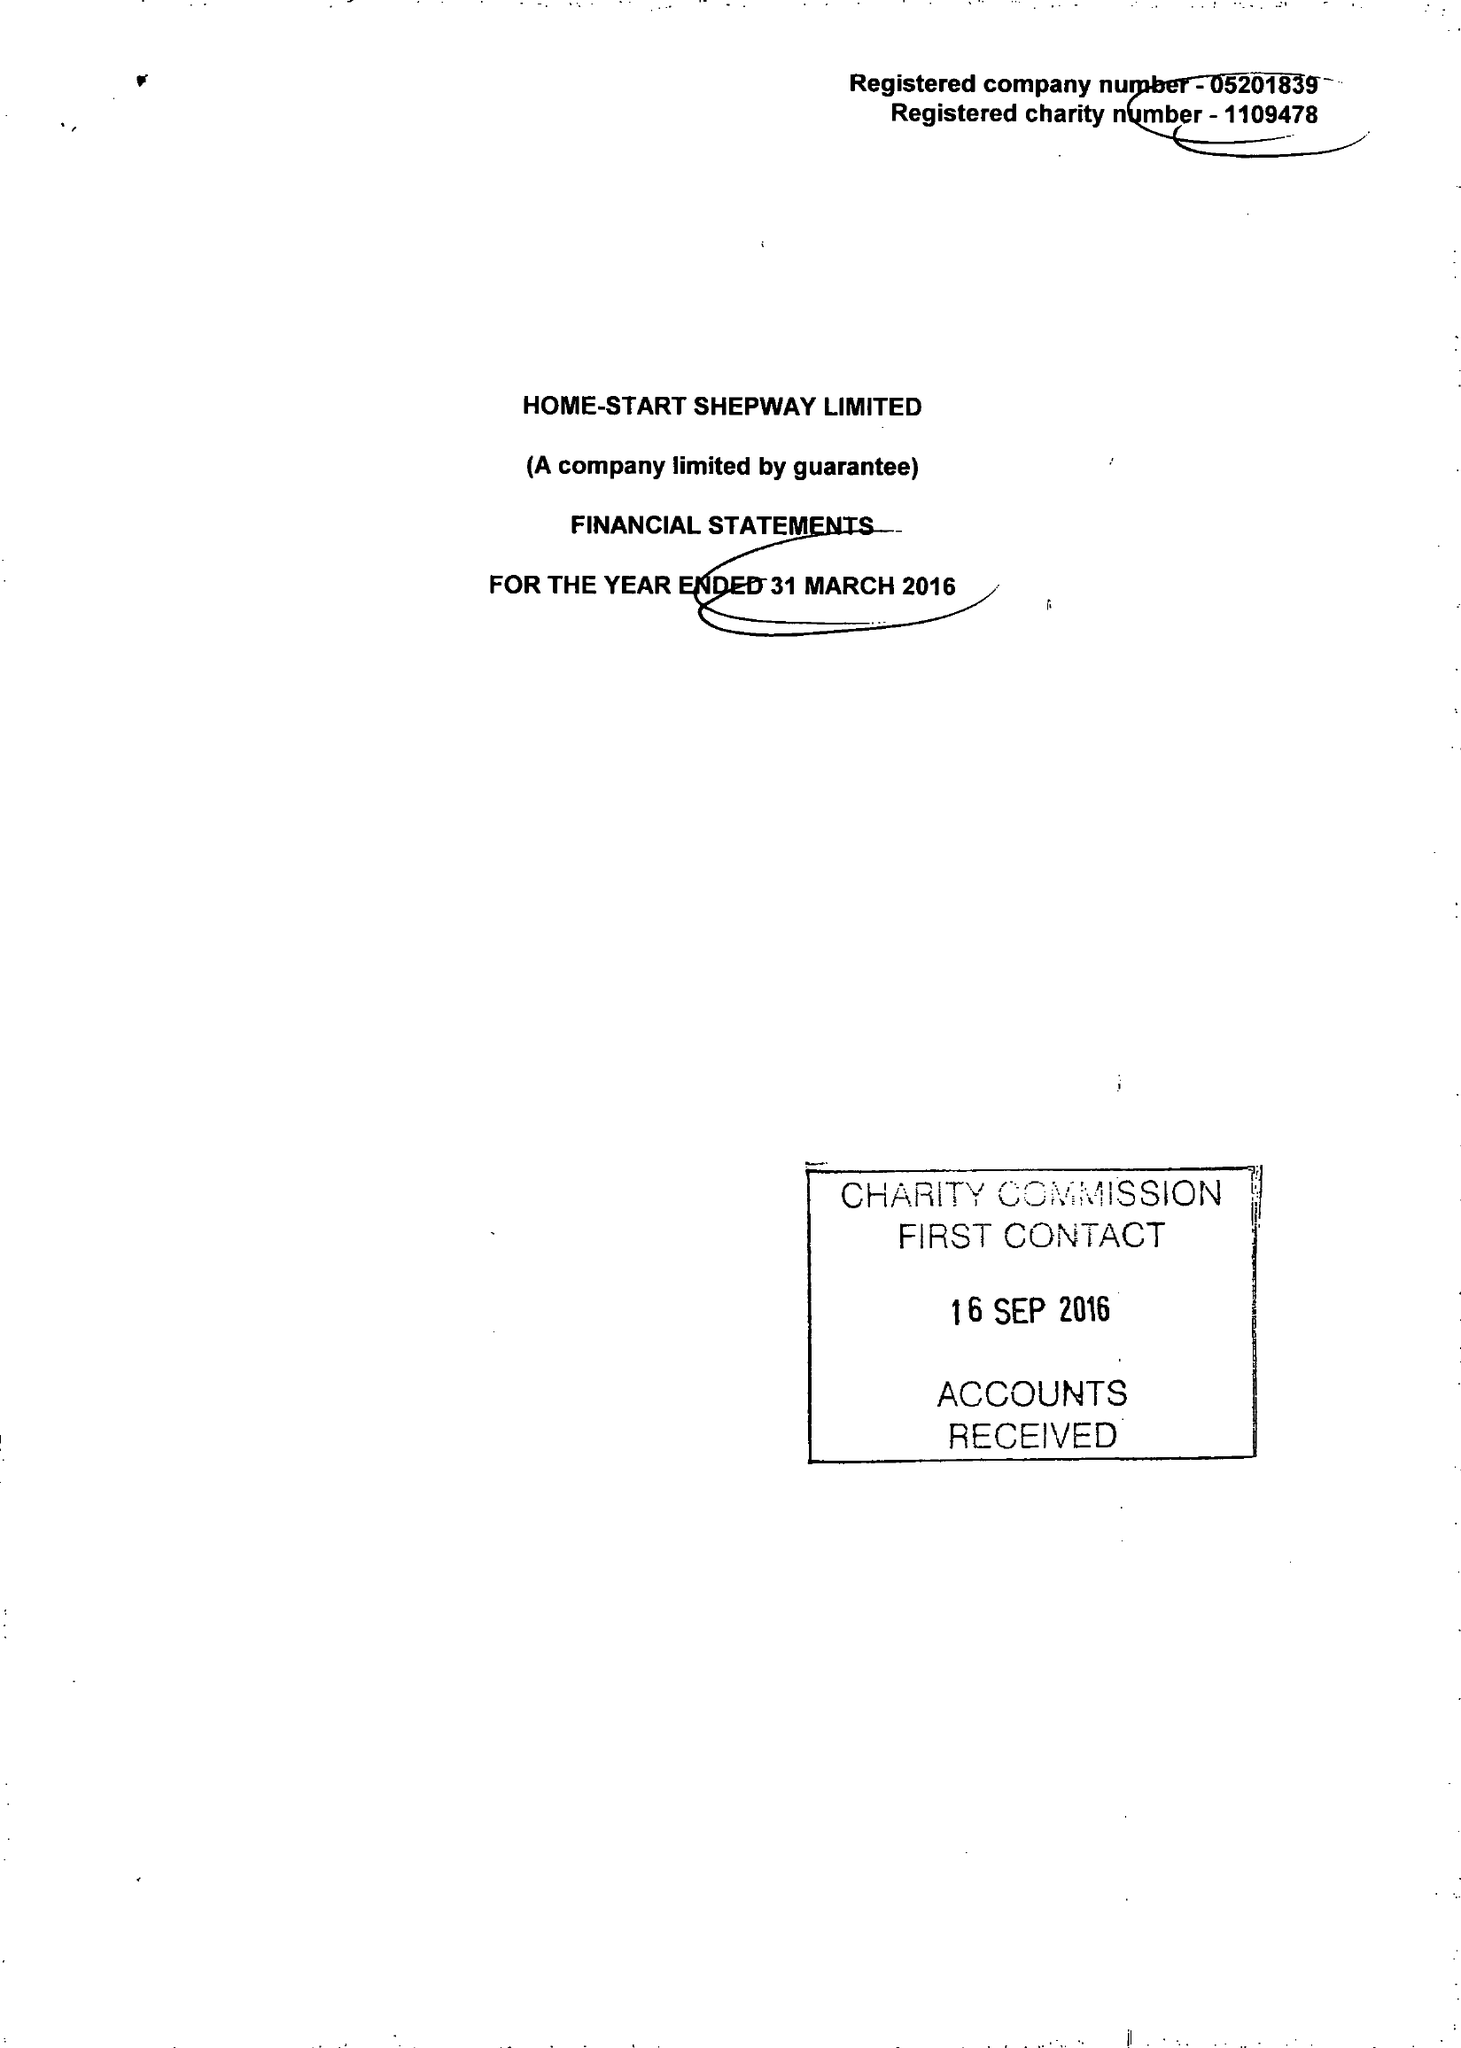What is the value for the spending_annually_in_british_pounds?
Answer the question using a single word or phrase. 347000.00 